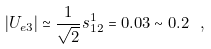<formula> <loc_0><loc_0><loc_500><loc_500>| U _ { e 3 } | \simeq \frac { 1 } { \sqrt { 2 } } s ^ { 1 } _ { 1 2 } = 0 . 0 3 \sim 0 . 2 \ ,</formula> 